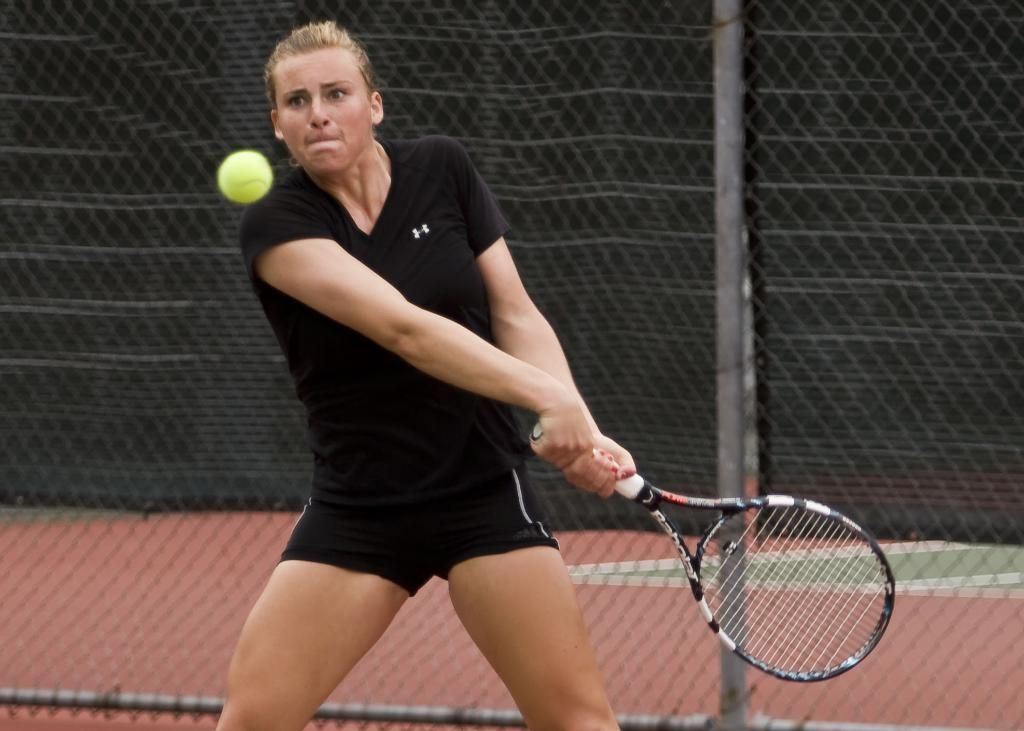What activity is the person in the image engaged in? The person is playing badminton in the image. What is the color of the bat the person is holding? The person is holding a black-colored bat. What object is used in the game of badminton in the image? There is a green-colored ball in the image. What can be seen in the background of the image? There is a railing visible in the background of the image. What type of chalk is the person using to draw on the court in the image? There is no chalk present in the image, and the person is not drawing on the court. 